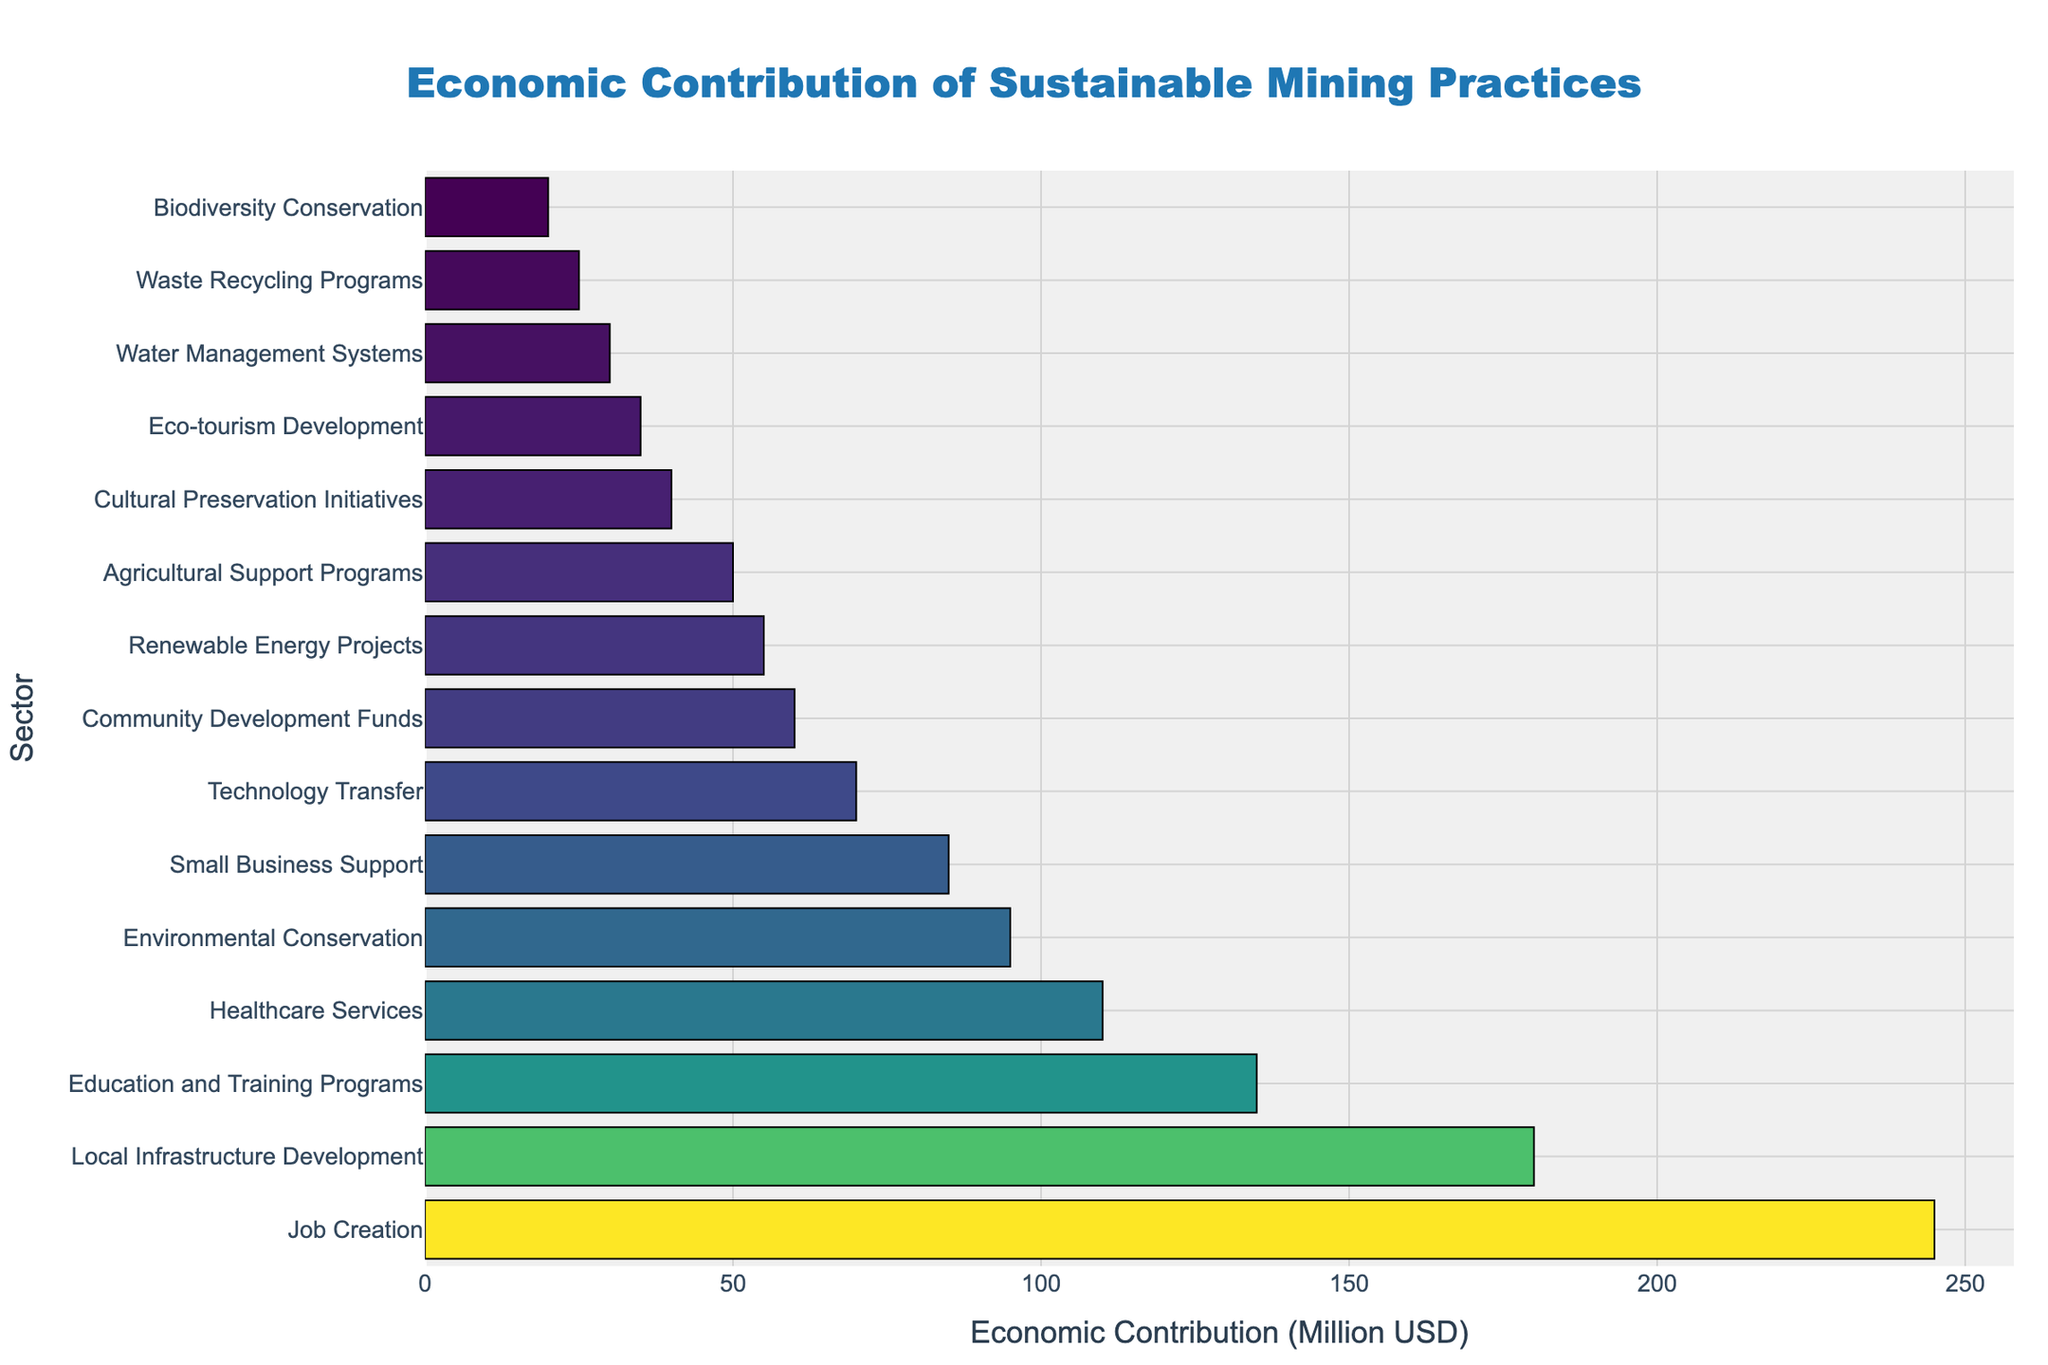What sector shows the highest economic contribution? Look at the bar with the greatest length in the figure. The sector corresponding to this bar shows the highest economic contribution.
Answer: Job Creation Which sector contributes more to the local economy, Healthcare Services or Renewable Energy Projects? Locate the bars corresponding to Healthcare Services and Renewable Energy Projects. Compare their lengths; the longer bar indicates the greater contribution.
Answer: Healthcare Services What is the total economic contribution of the top three sectors? Identify the top three sectors by locating the three longest bars. Add their values together: Job Creation (245), Local Infrastructure Development (180), and Education and Training Programs (135). The sum is 245 + 180 + 135.
Answer: 560 Which sector shows the lowest economic contribution, and what is its value? Locate the bar with the shortest length in the figure. The sector corresponding to this bar shows the lowest economic contribution, and read the value from the x-axis.
Answer: Biodiversity Conservation, 20 How much more does the Education and Training Programs sector contribute compared to the Water Management Systems sector? Locate the bars for both sectors. Subtract the value of Water Management Systems from Education and Training Programs: 135 - 30.
Answer: 105 What is the average economic contribution of Cultural Preservation Initiatives, Eco-tourism Development, and Waste Recycling Programs? Identify the bars for each of these sectors and read their values: Cultural Preservation Initiatives (40), Eco-tourism Development (35), and Waste Recycling Programs (25). Calculate the average: (40 + 35 + 25) / 3.
Answer: 33.33 Are there more sectors contributing over 100 million USD or under 100 million USD? Count the number of bars with contributions over 100 million USD and under 100 million USD. Over 100 million: Job Creation, Local Infrastructure Development, Education and Training Programs, Healthcare Services. Under 100 million: the rest. Compare the counts: 4 sectors over 100M, 11 sectors under 100M.
Answer: Under 100 million USD Which sector has an economic contribution closest to 50 million USD? Identify the bar that is closest to the 50 million USD mark on the x-axis.
Answer: Agricultural Support Programs What is the combined economic contribution of sectors contributing less than 40 million USD? Identify all sectors with contributions less than 40 million USD and add their values: Biodiversity Conservation (20), Waste Recycling Programs (25), Water Management Systems (30), Eco-tourism Development (35), Cultural Preservation Initiatives (40, but this is excluded since it equals 40). The sum is 20 + 25 + 30 + 35.
Answer: 110 